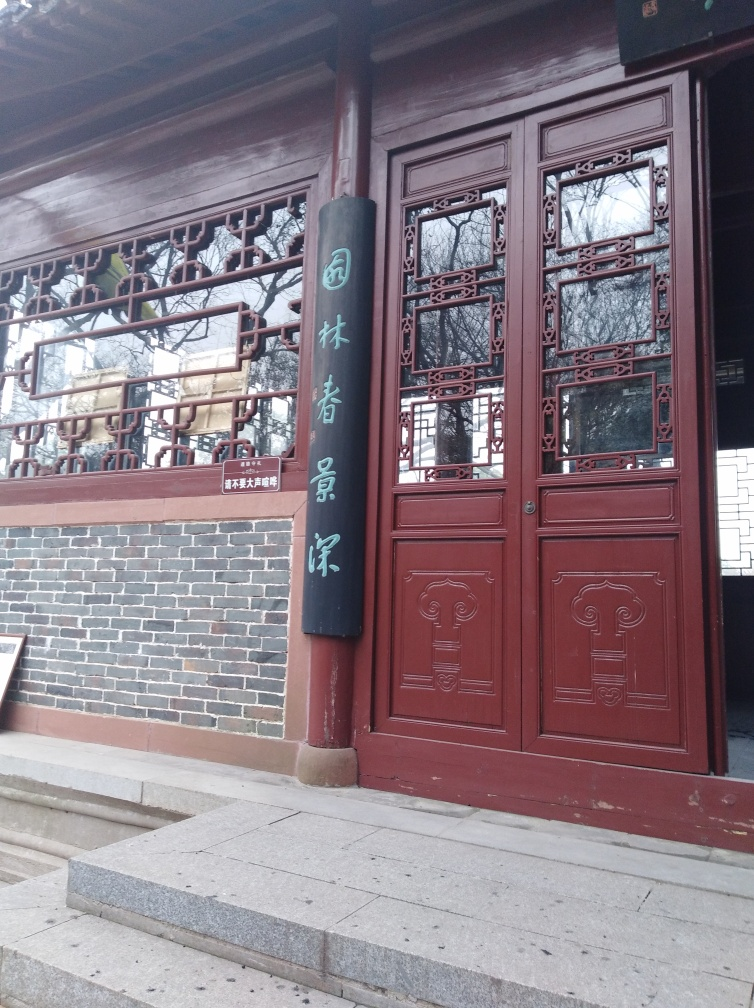What might the characters on the sign translate to? The characters on the sign are written in Chinese and could be indicative of a name or a phrase of significance associated with the building; however, without a clear understanding of the context or additional information, a precise translation is not possible here. Could the text be related to the building's purpose? Yes, it's common for such signs in Chinese architecture to relate to the building's function or history, such as denoting a temple's name, the name of a historical figure associated with the site, or a philosophical or poetic phrase. 